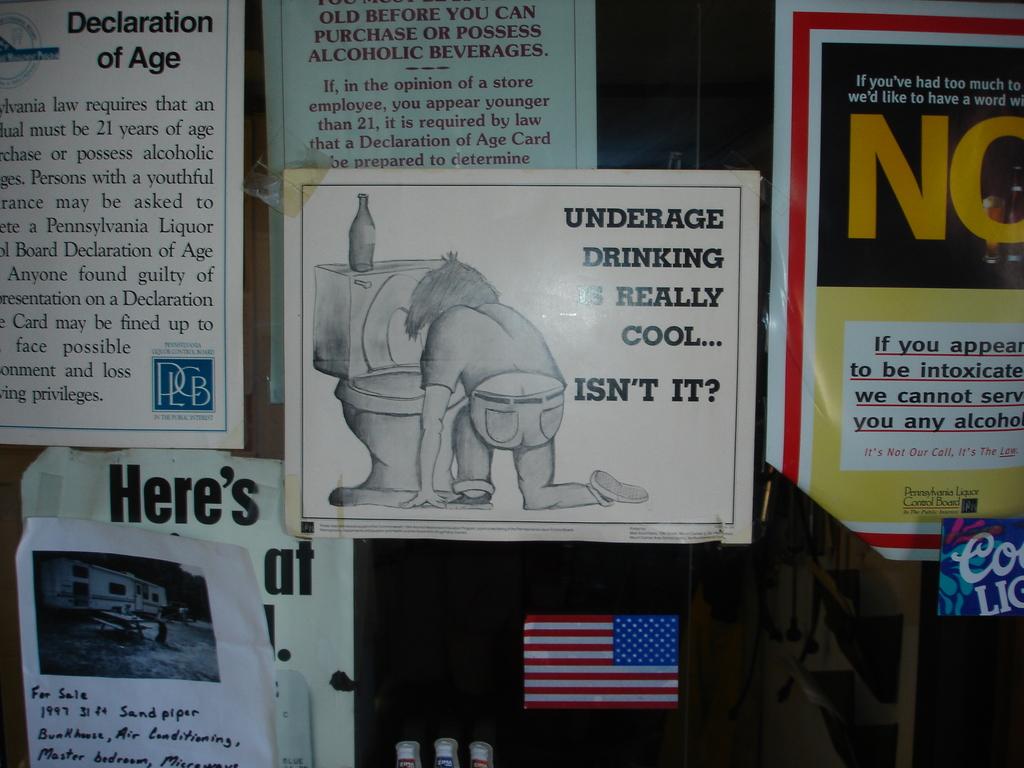Is underage drinking cool?
Make the answer very short. Unanswerable. 